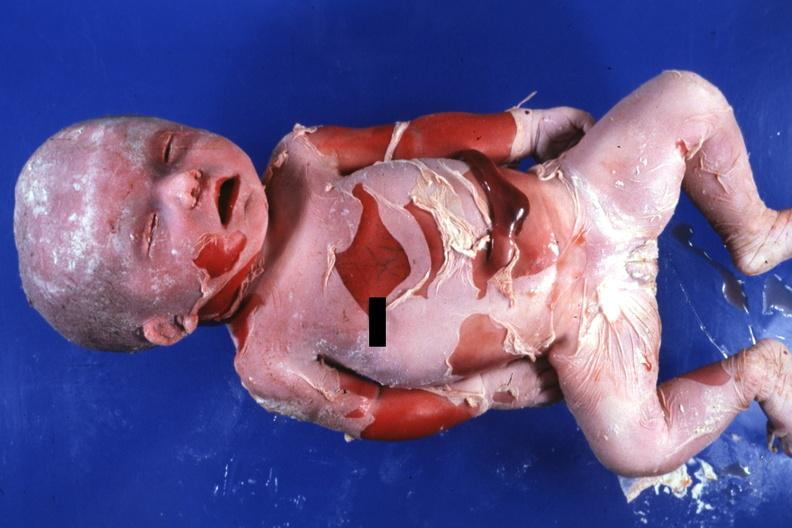what advanced typical?
Answer the question using a single word or phrase. Natural color 